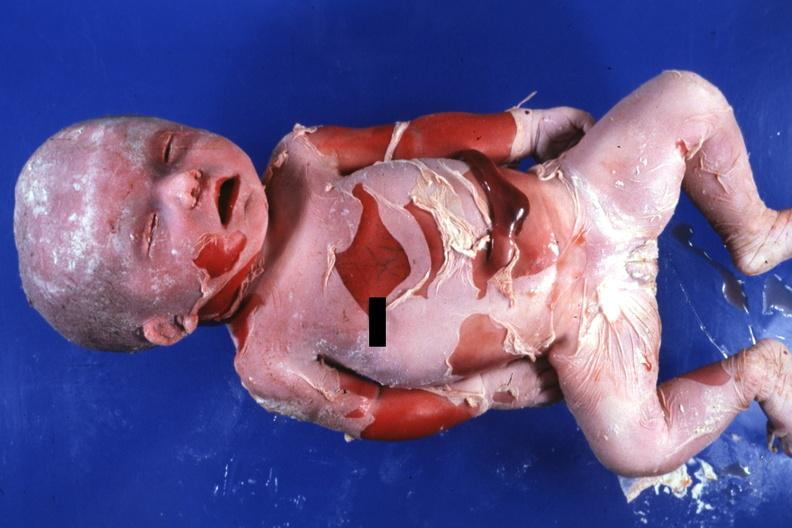what advanced typical?
Answer the question using a single word or phrase. Natural color 